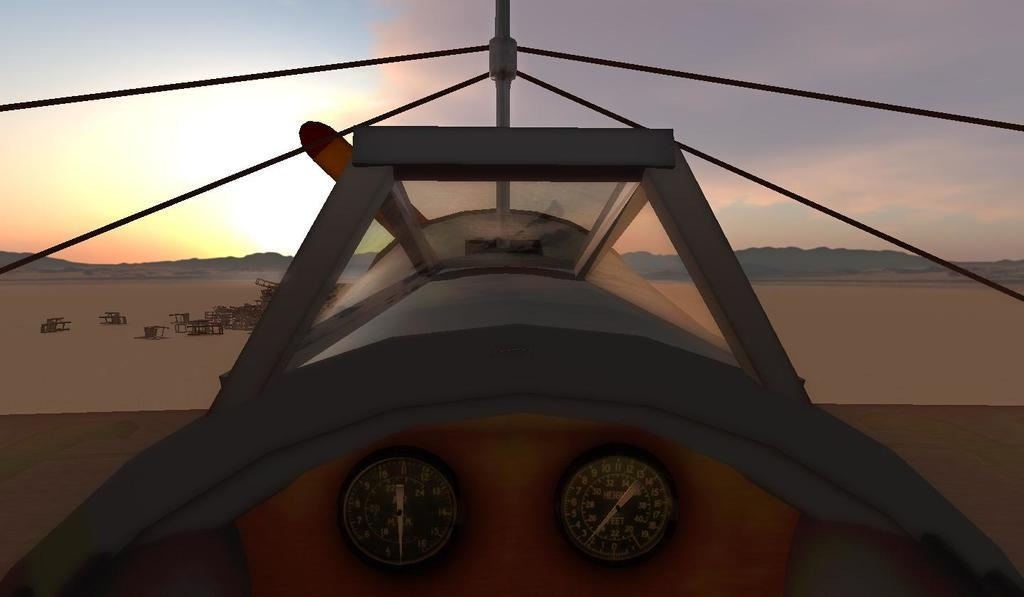<image>
Relay a brief, clear account of the picture shown. inside of small plane that has 2 gauges, one has words height feet and dial a little past 2 